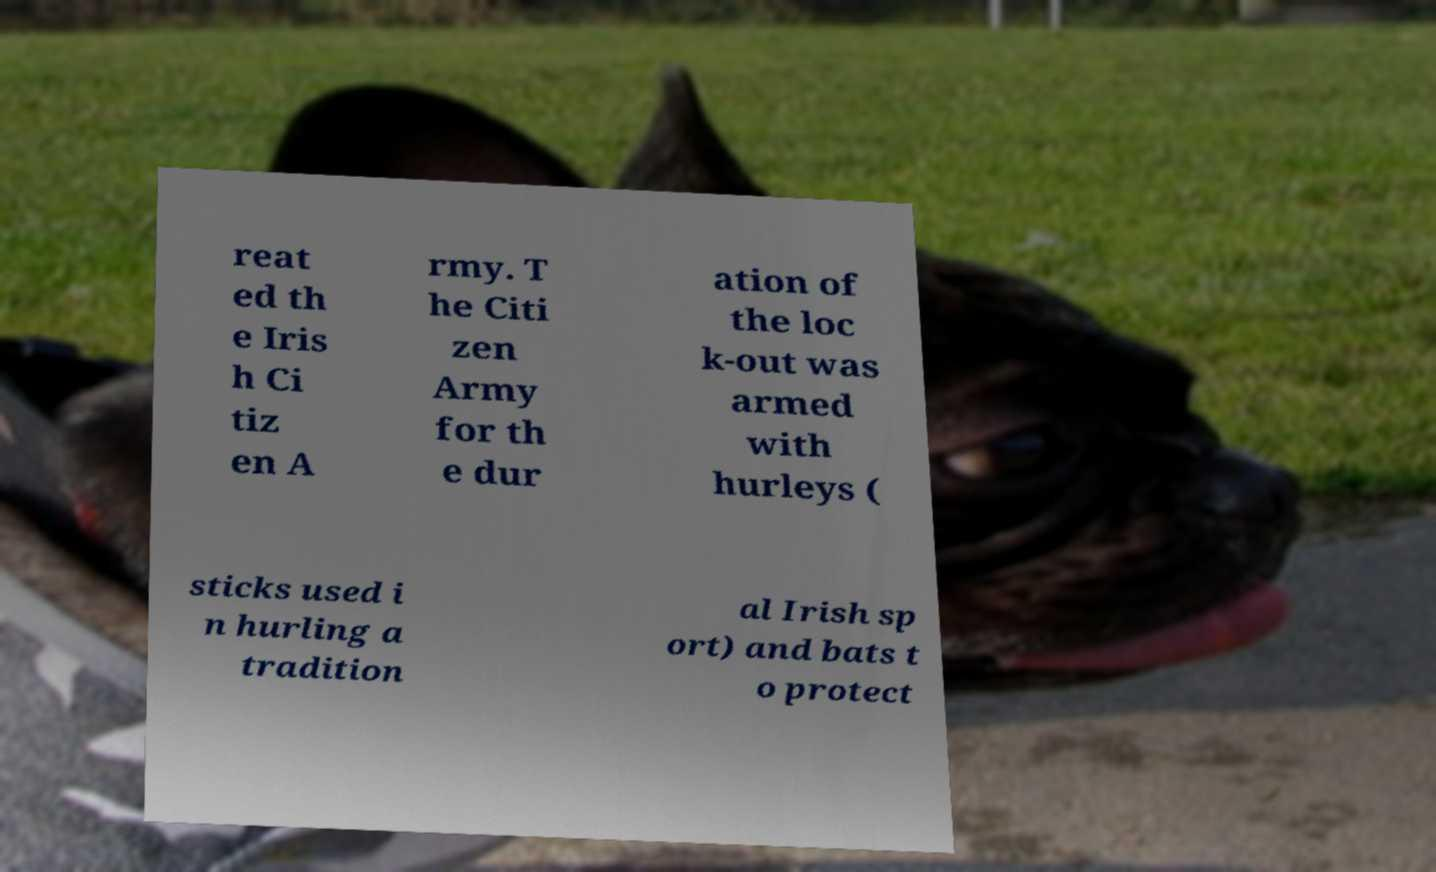Can you accurately transcribe the text from the provided image for me? reat ed th e Iris h Ci tiz en A rmy. T he Citi zen Army for th e dur ation of the loc k-out was armed with hurleys ( sticks used i n hurling a tradition al Irish sp ort) and bats t o protect 